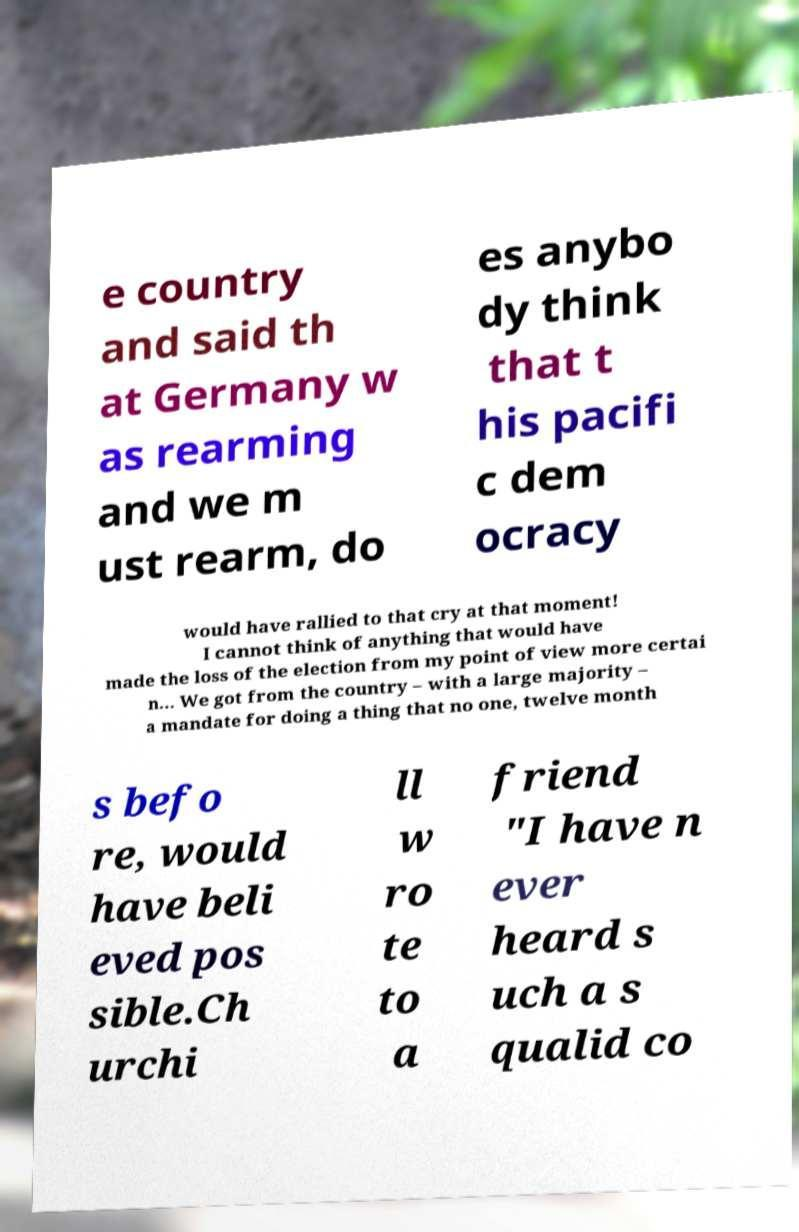Can you accurately transcribe the text from the provided image for me? e country and said th at Germany w as rearming and we m ust rearm, do es anybo dy think that t his pacifi c dem ocracy would have rallied to that cry at that moment! I cannot think of anything that would have made the loss of the election from my point of view more certai n... We got from the country – with a large majority – a mandate for doing a thing that no one, twelve month s befo re, would have beli eved pos sible.Ch urchi ll w ro te to a friend "I have n ever heard s uch a s qualid co 